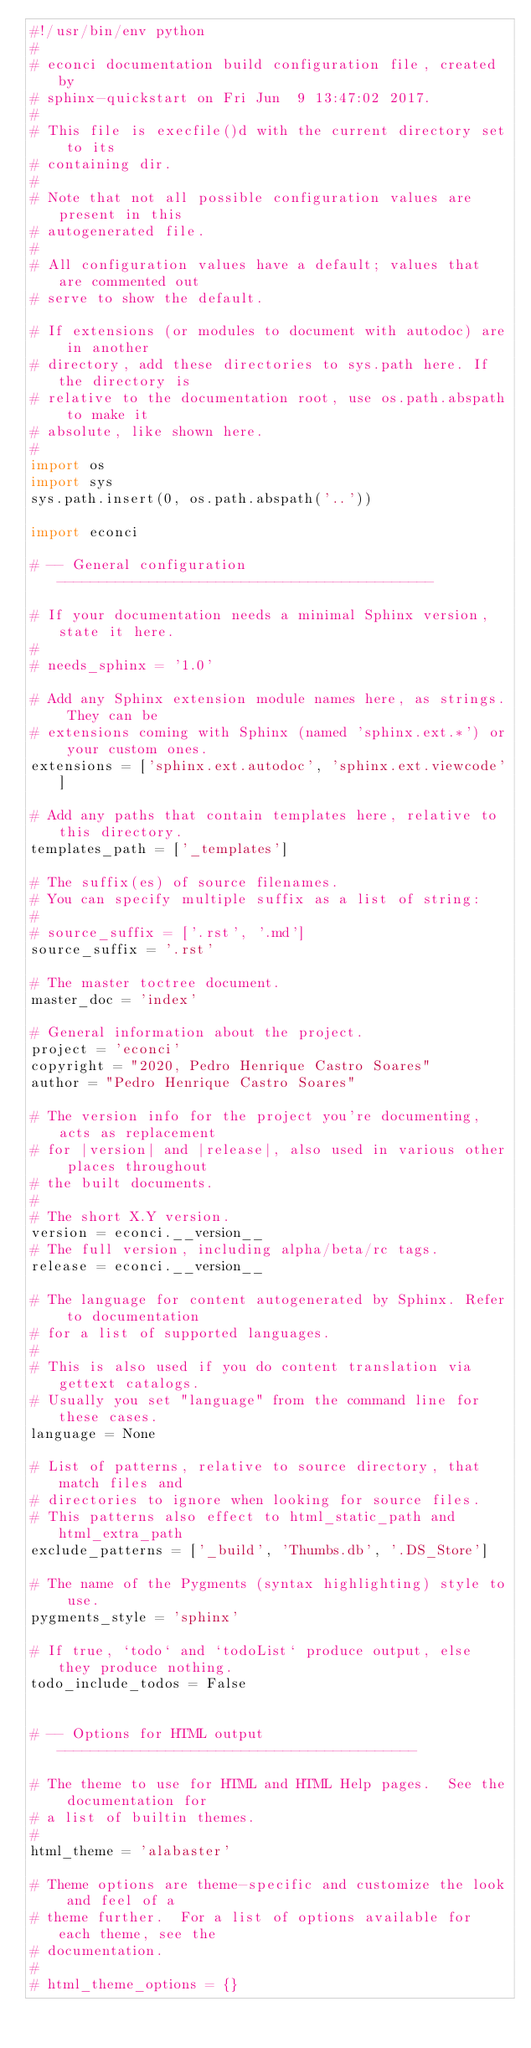<code> <loc_0><loc_0><loc_500><loc_500><_Python_>#!/usr/bin/env python
#
# econci documentation build configuration file, created by
# sphinx-quickstart on Fri Jun  9 13:47:02 2017.
#
# This file is execfile()d with the current directory set to its
# containing dir.
#
# Note that not all possible configuration values are present in this
# autogenerated file.
#
# All configuration values have a default; values that are commented out
# serve to show the default.

# If extensions (or modules to document with autodoc) are in another
# directory, add these directories to sys.path here. If the directory is
# relative to the documentation root, use os.path.abspath to make it
# absolute, like shown here.
#
import os
import sys
sys.path.insert(0, os.path.abspath('..'))

import econci

# -- General configuration ---------------------------------------------

# If your documentation needs a minimal Sphinx version, state it here.
#
# needs_sphinx = '1.0'

# Add any Sphinx extension module names here, as strings. They can be
# extensions coming with Sphinx (named 'sphinx.ext.*') or your custom ones.
extensions = ['sphinx.ext.autodoc', 'sphinx.ext.viewcode']

# Add any paths that contain templates here, relative to this directory.
templates_path = ['_templates']

# The suffix(es) of source filenames.
# You can specify multiple suffix as a list of string:
#
# source_suffix = ['.rst', '.md']
source_suffix = '.rst'

# The master toctree document.
master_doc = 'index'

# General information about the project.
project = 'econci'
copyright = "2020, Pedro Henrique Castro Soares"
author = "Pedro Henrique Castro Soares"

# The version info for the project you're documenting, acts as replacement
# for |version| and |release|, also used in various other places throughout
# the built documents.
#
# The short X.Y version.
version = econci.__version__
# The full version, including alpha/beta/rc tags.
release = econci.__version__

# The language for content autogenerated by Sphinx. Refer to documentation
# for a list of supported languages.
#
# This is also used if you do content translation via gettext catalogs.
# Usually you set "language" from the command line for these cases.
language = None

# List of patterns, relative to source directory, that match files and
# directories to ignore when looking for source files.
# This patterns also effect to html_static_path and html_extra_path
exclude_patterns = ['_build', 'Thumbs.db', '.DS_Store']

# The name of the Pygments (syntax highlighting) style to use.
pygments_style = 'sphinx'

# If true, `todo` and `todoList` produce output, else they produce nothing.
todo_include_todos = False


# -- Options for HTML output -------------------------------------------

# The theme to use for HTML and HTML Help pages.  See the documentation for
# a list of builtin themes.
#
html_theme = 'alabaster'

# Theme options are theme-specific and customize the look and feel of a
# theme further.  For a list of options available for each theme, see the
# documentation.
#
# html_theme_options = {}
</code> 